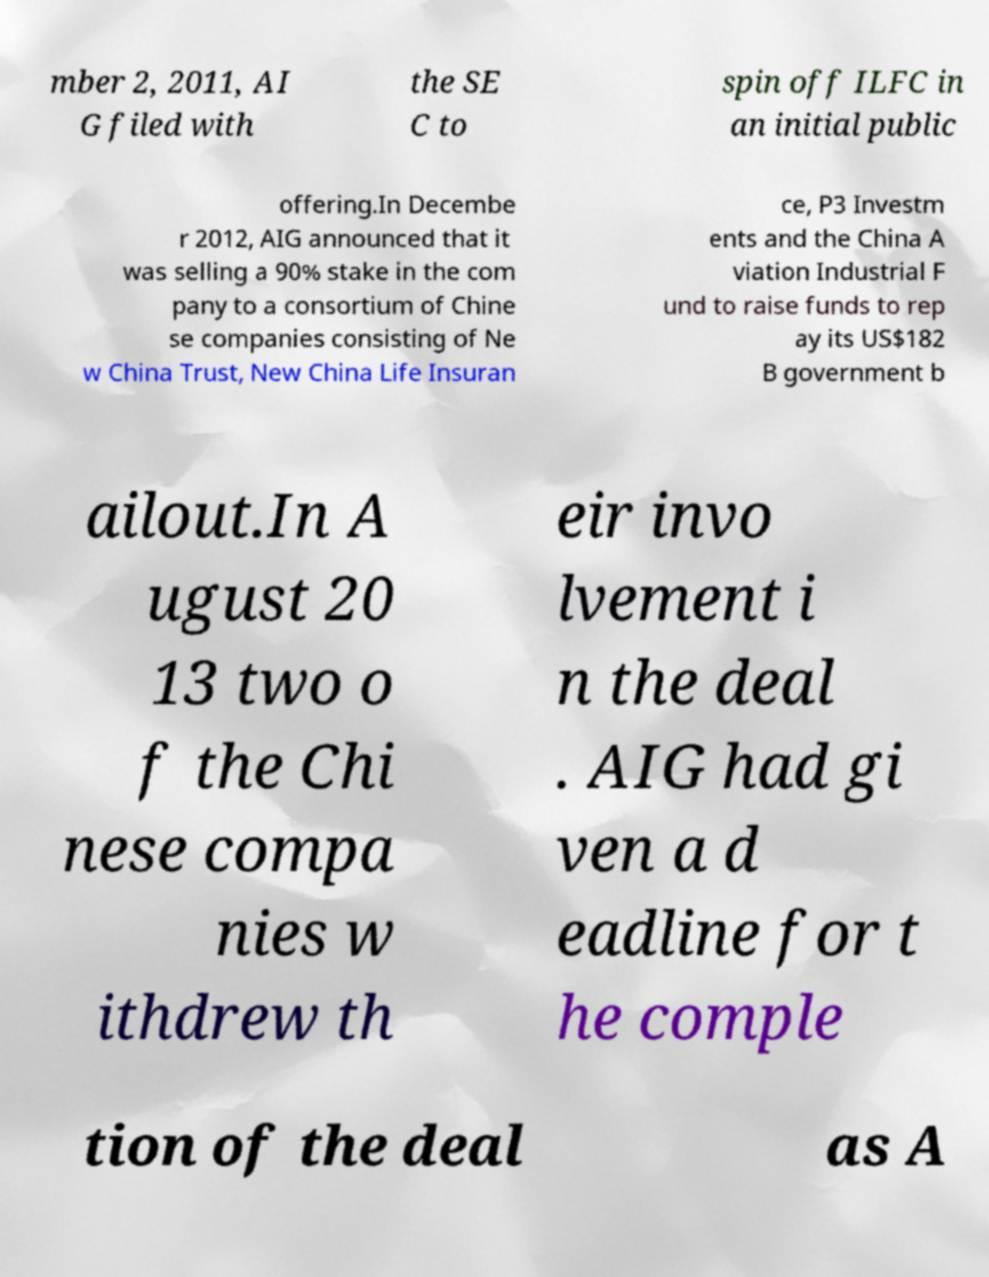Could you extract and type out the text from this image? mber 2, 2011, AI G filed with the SE C to spin off ILFC in an initial public offering.In Decembe r 2012, AIG announced that it was selling a 90% stake in the com pany to a consortium of Chine se companies consisting of Ne w China Trust, New China Life Insuran ce, P3 Investm ents and the China A viation Industrial F und to raise funds to rep ay its US$182 B government b ailout.In A ugust 20 13 two o f the Chi nese compa nies w ithdrew th eir invo lvement i n the deal . AIG had gi ven a d eadline for t he comple tion of the deal as A 